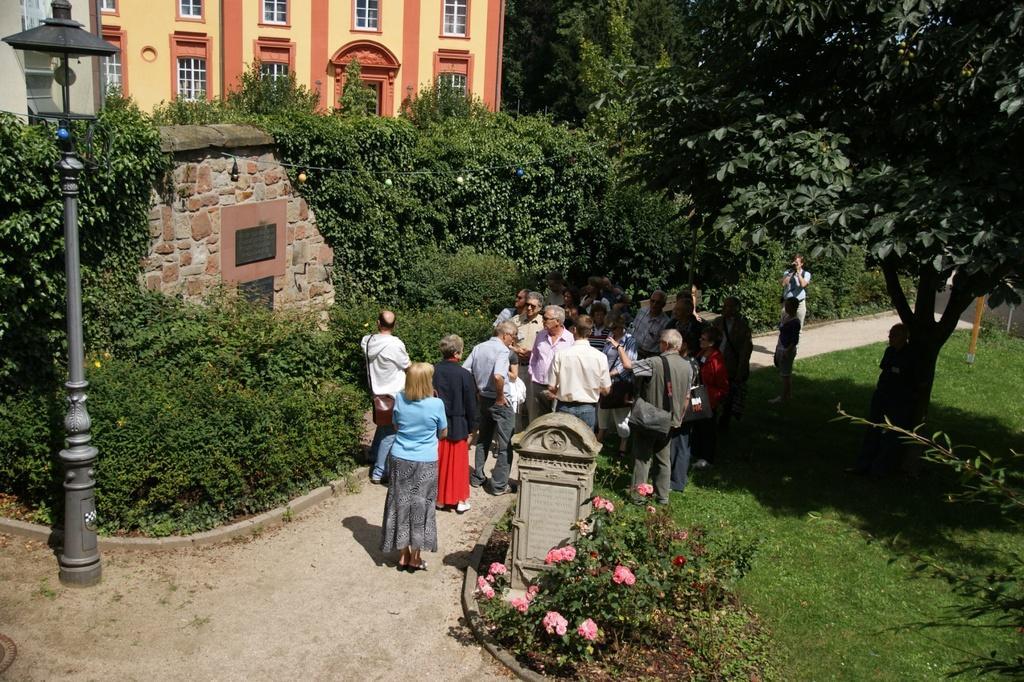In one or two sentences, can you explain what this image depicts? In this picture I can see at the bottom there are flower plants, in the middle a group of people are standing, on the left side there is a lamp. On the right side there are trees, at the top there is a building. 